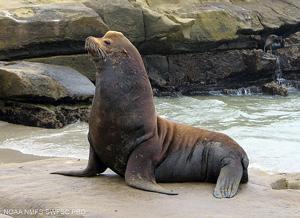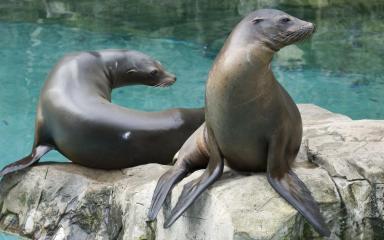The first image is the image on the left, the second image is the image on the right. Analyze the images presented: Is the assertion "The right image contains two seals." valid? Answer yes or no. Yes. The first image is the image on the left, the second image is the image on the right. For the images shown, is this caption "The right image includes a sleek gray seal with raised right-turned head and body turned to the camera, perched on a large rock in front of blue-green water." true? Answer yes or no. Yes. 